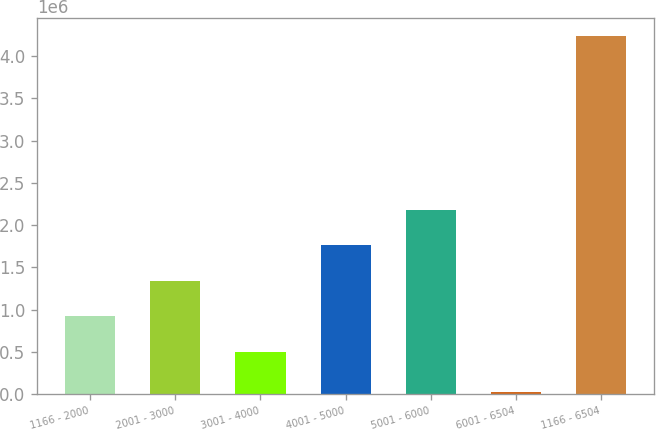Convert chart. <chart><loc_0><loc_0><loc_500><loc_500><bar_chart><fcel>1166 - 2000<fcel>2001 - 3000<fcel>3001 - 4000<fcel>4001 - 5000<fcel>5001 - 6000<fcel>6001 - 6504<fcel>1166 - 6504<nl><fcel>920200<fcel>1.3414e+06<fcel>499000<fcel>1.7626e+06<fcel>2.1838e+06<fcel>26000<fcel>4.238e+06<nl></chart> 